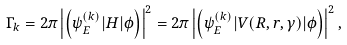Convert formula to latex. <formula><loc_0><loc_0><loc_500><loc_500>\Gamma _ { k } = 2 \pi \left | \left ( \psi _ { E } ^ { ( k ) } | H | \phi \right ) \right | ^ { 2 } = 2 \pi \left | \left ( \psi _ { E } ^ { ( k ) } | V ( R , r , \gamma ) | \phi \right ) \right | ^ { 2 } ,</formula> 